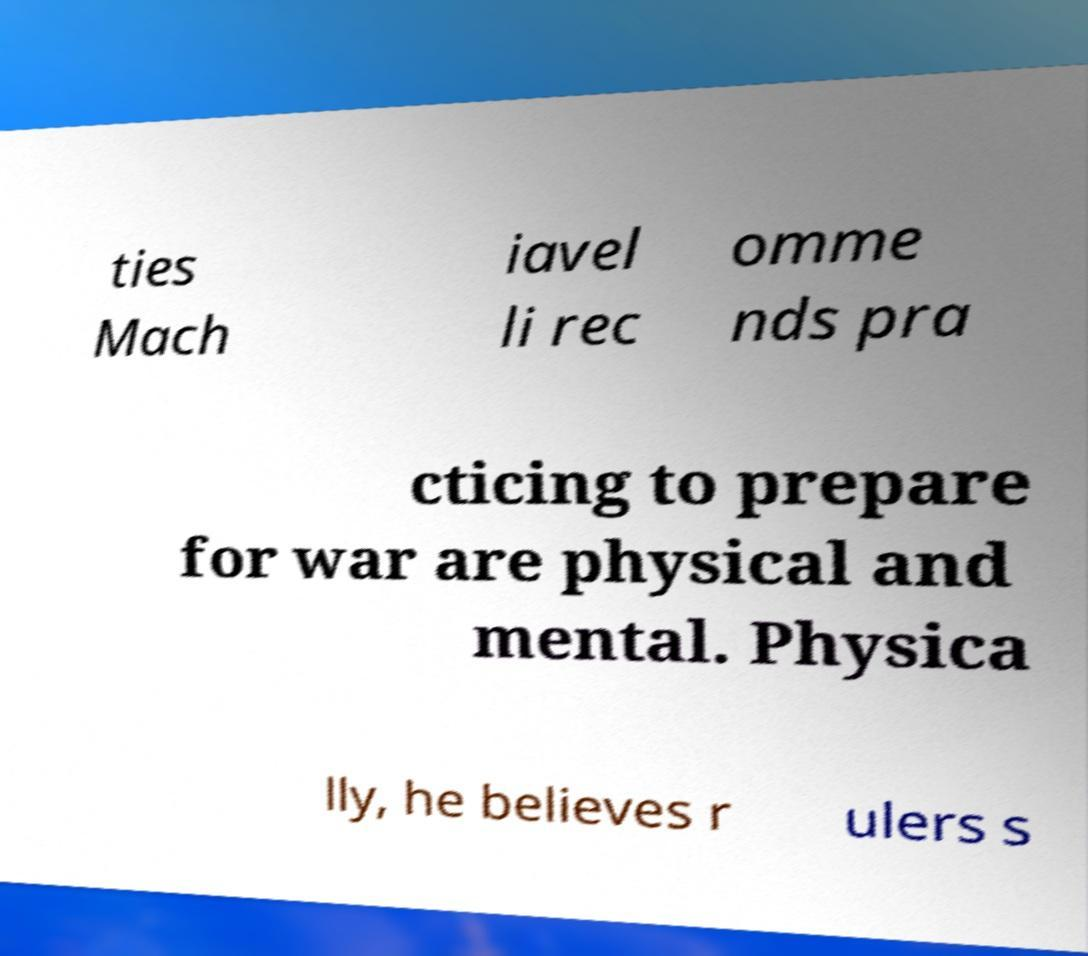There's text embedded in this image that I need extracted. Can you transcribe it verbatim? ties Mach iavel li rec omme nds pra cticing to prepare for war are physical and mental. Physica lly, he believes r ulers s 